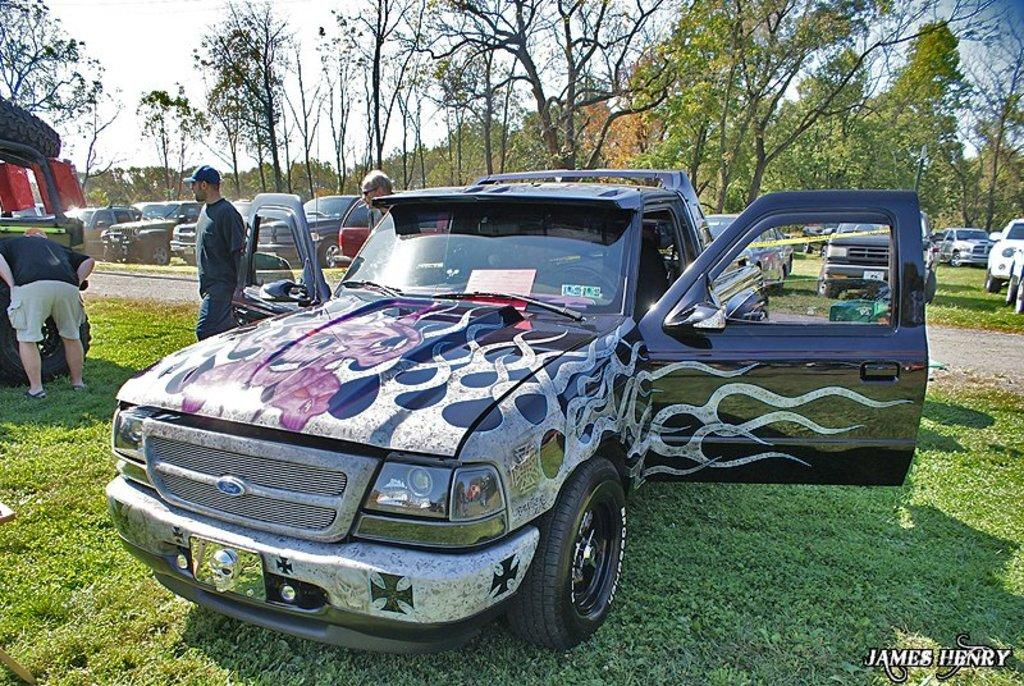What is the main subject of the image? The main subject of the image is many cars. Can you describe the people in the image? There are three men in between the cars. What can be seen in the background of the image? There are many trees in the background of the image. What type of copper material can be seen on the cars in the image? There is no copper material visible on the cars in the image. What direction are the cars facing in the image? The direction the cars are facing cannot be determined from the image. 